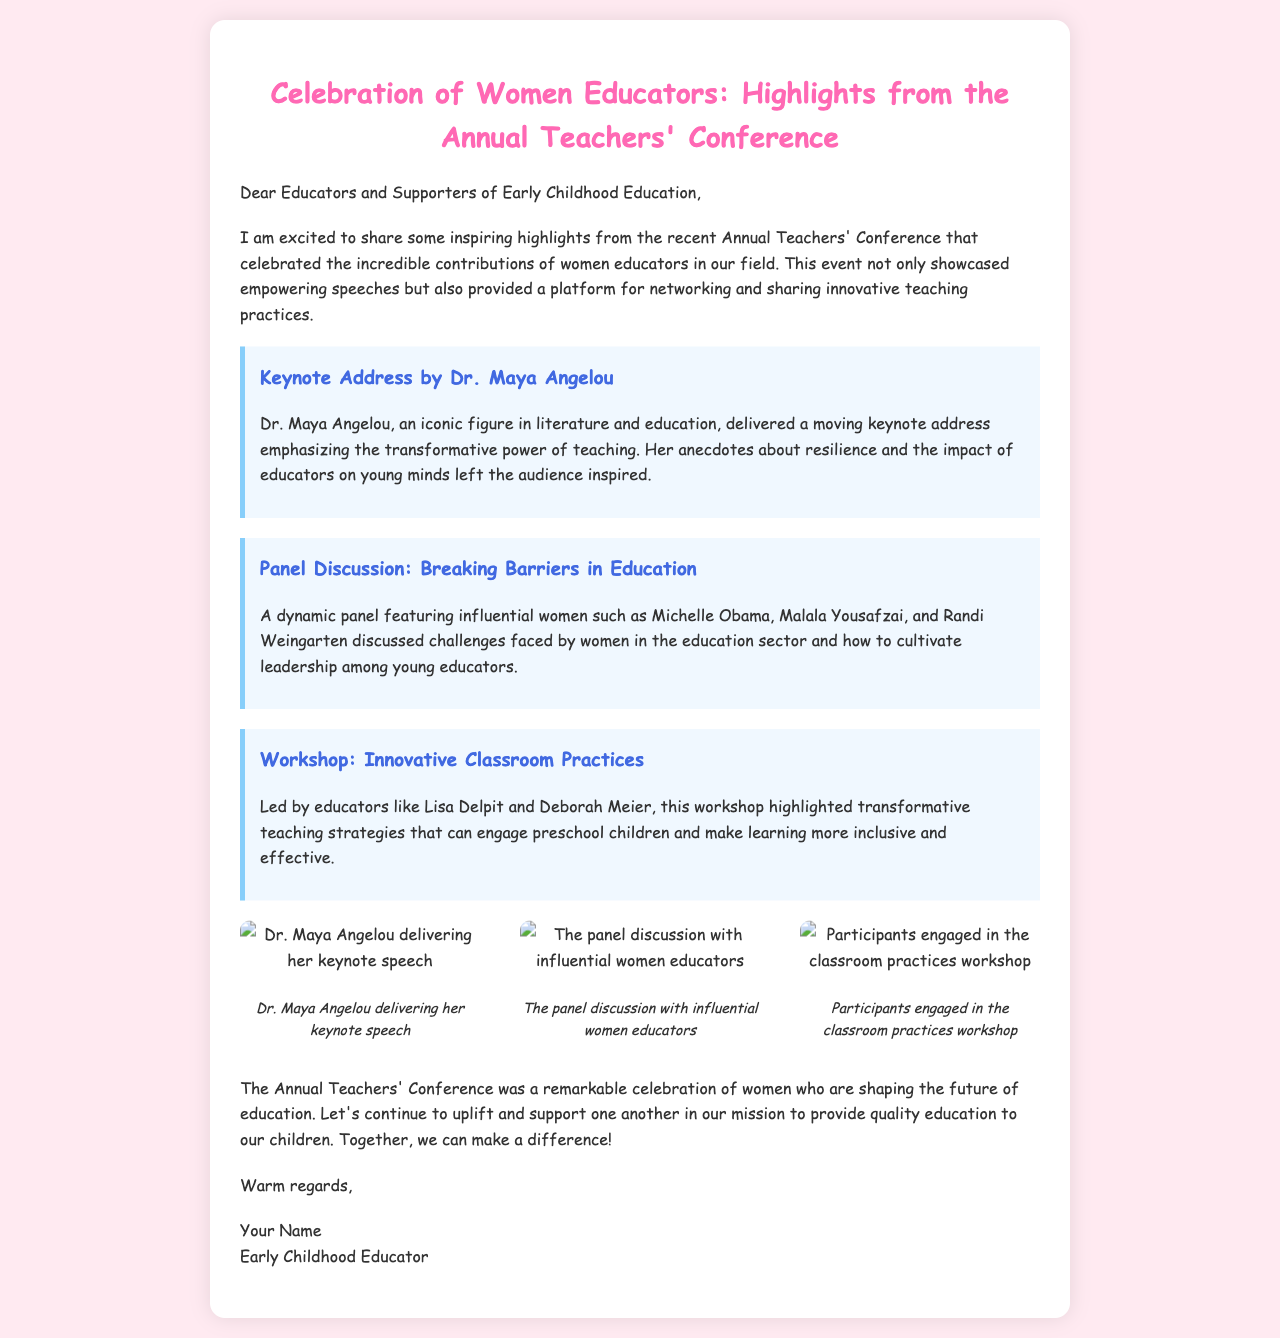What is the title of the event? The title of the event is stated at the beginning of the document.
Answer: Celebration of Women Educators: Highlights from the Annual Teachers' Conference Who delivered the keynote address? The document mentions Dr. Maya Angelou as the keynote speaker.
Answer: Dr. Maya Angelou What was a topic discussed in the panel? The document provides information on the topic of challenges faced by women in education during the panel discussion.
Answer: Breaking Barriers in Education Which two educators led the workshop on classroom practices? The document lists educators Lisa Delpit and Deborah Meier as leaders of the workshop.
Answer: Lisa Delpit and Deborah Meier How many photos are included in the document? The document features a gallery with three photos.
Answer: 3 What is the main message of Dr. Maya Angelou's address? The document summarizes the theme of Dr. Maya Angelou's address regarding teaching.
Answer: Transformative power of teaching What is the conclusion of the document regarding women's role in education? The document's final thoughts emphasize supporting women in education.
Answer: Uplift and support What type of document is this? This document is an email summarizing an event.
Answer: Email 